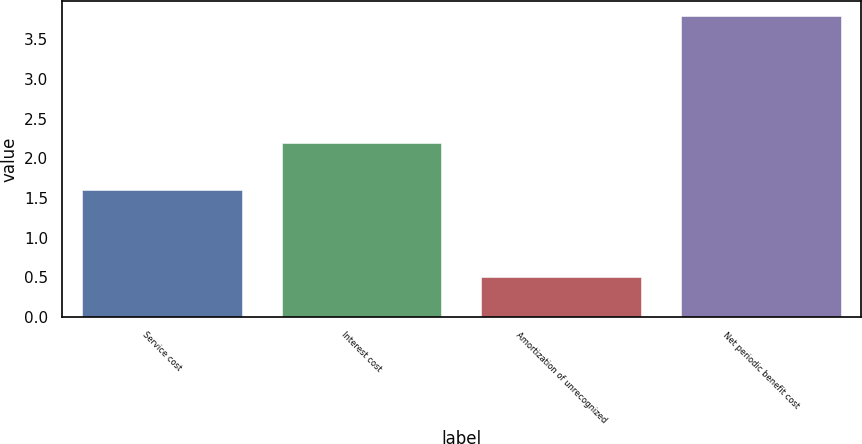Convert chart to OTSL. <chart><loc_0><loc_0><loc_500><loc_500><bar_chart><fcel>Service cost<fcel>Interest cost<fcel>Amortization of unrecognized<fcel>Net periodic benefit cost<nl><fcel>1.6<fcel>2.2<fcel>0.5<fcel>3.8<nl></chart> 